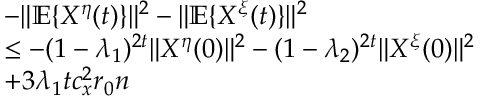Convert formula to latex. <formula><loc_0><loc_0><loc_500><loc_500>\begin{array} { r l } & { - \| \mathbb { E } \{ X ^ { \eta } ( t ) \} \| ^ { 2 } - \| \mathbb { E } \{ X ^ { \xi } ( t ) \} \| ^ { 2 } } \\ & { \leq - ( 1 - \lambda _ { 1 } ) ^ { 2 t } \| X ^ { \eta } ( 0 ) \| ^ { 2 } - ( 1 - \lambda _ { 2 } ) ^ { 2 t } \| X ^ { \xi } ( 0 ) \| ^ { 2 } } \\ & { + 3 \lambda _ { 1 } t c _ { x } ^ { 2 } r _ { 0 } n } \end{array}</formula> 